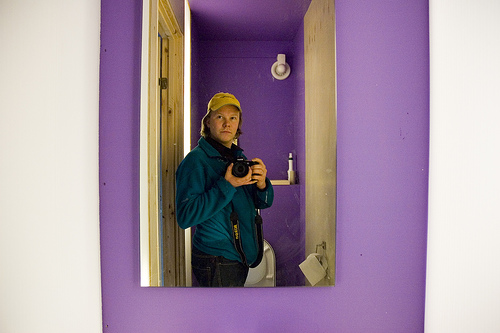<image>
Is there a mirror on the purple wall? Yes. Looking at the image, I can see the mirror is positioned on top of the purple wall, with the purple wall providing support. 